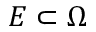<formula> <loc_0><loc_0><loc_500><loc_500>E \subset \Omega</formula> 